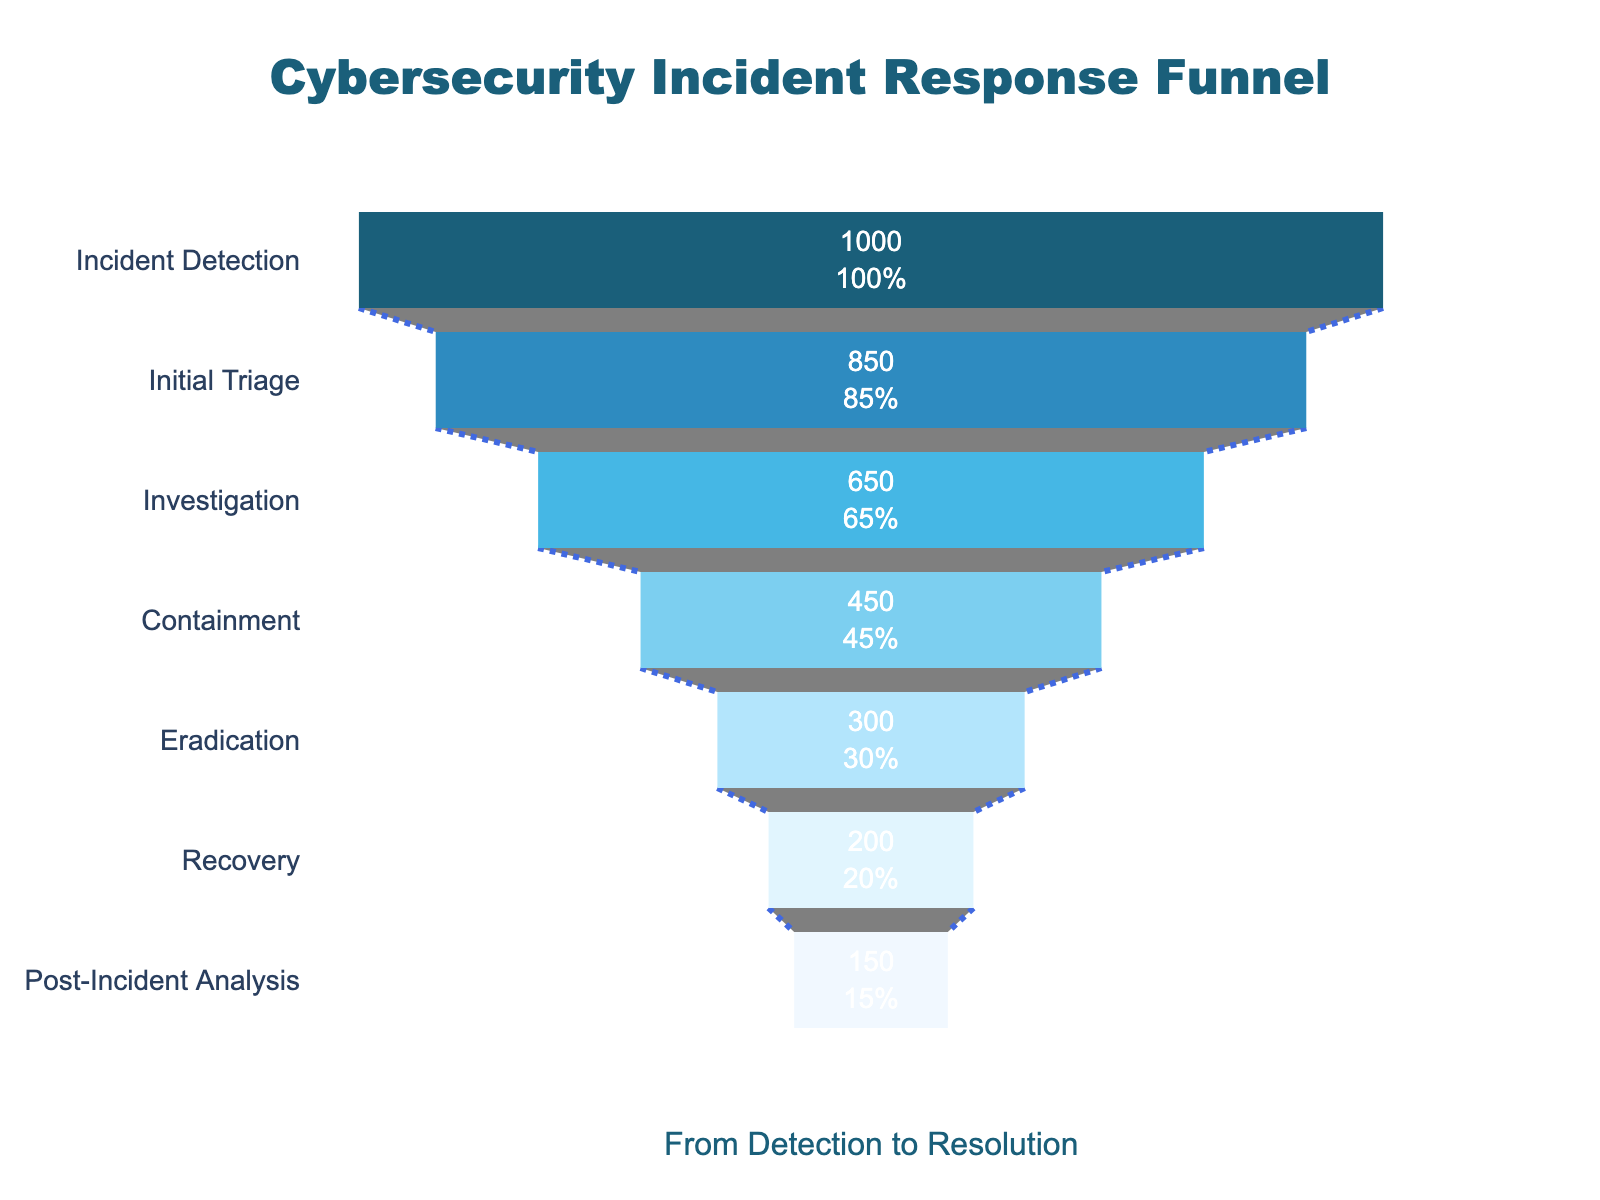How many stages are depicted in the funnel chart? The chart depicts the stages of the cybersecurity incident response process and each stage corresponds to a different part of the funnel. To answer, count the number of stages listed on the y-axis.
Answer: 7 What is the title of the funnel chart? The title is usually displayed prominently at the top of the chart. Look at the main text at the top center of the chart to find the title.
Answer: Cybersecurity Incident Response Funnel What is the percentage of incidents that reach the Investigation stage? The number of incidents at the Investigation stage is 650 out of the initial 1000 incidents detected. Calculate the percentage by (650/1000) * 100.
Answer: 65% Which stage has the fewest incidents? To find the stage with the fewest incidents, compare the count values of all stages. The stage with the smallest count value has the fewest incidents.
Answer: Post-Incident Analysis What is the difference in the number of incidents between the Initial Triage and Containment stages? Subtract the number of incidents at the Containment stage from the number at the Initial Triage stage. Perform the calculation 850 - 450.
Answer: 400 Which two stages have a decline of 200 incidents from one to the next? Compare the incident counts between consecutive stages to find a pair where the difference is 200. Look through the counts to identify these stages.
Answer: Investigation and Containment What is the ratio of incidents at the Containment stage to incidents at the Initial Triage stage? To find the ratio, divide the number of incidents at the Containment stage by the number at the Initial Triage stage. Perform the calculation 450 / 850.
Answer: 0.53 How many stages have fewer than 500 incidents? To determine this, count the stages where the number of incidents is less than 500. Compare each stage's count to 500 and tally those less than this threshold.
Answer: 4 What percentage of incidents detected were resolved by the Post-Incident Analysis stage? The number of incidents resolved by Post-Incident Analysis stage is 150 out of the initial 1000 detected. Calculate the percentage by (150/1000) * 100.
Answer: 15% How does the text information in the chart describe the data? The text information inside the funnel segments generally includes values and percentages relative to the initial number of incidents. It helps to easily see the value at each stage and its percentage drop from the start.
Answer: Value and percent initial 